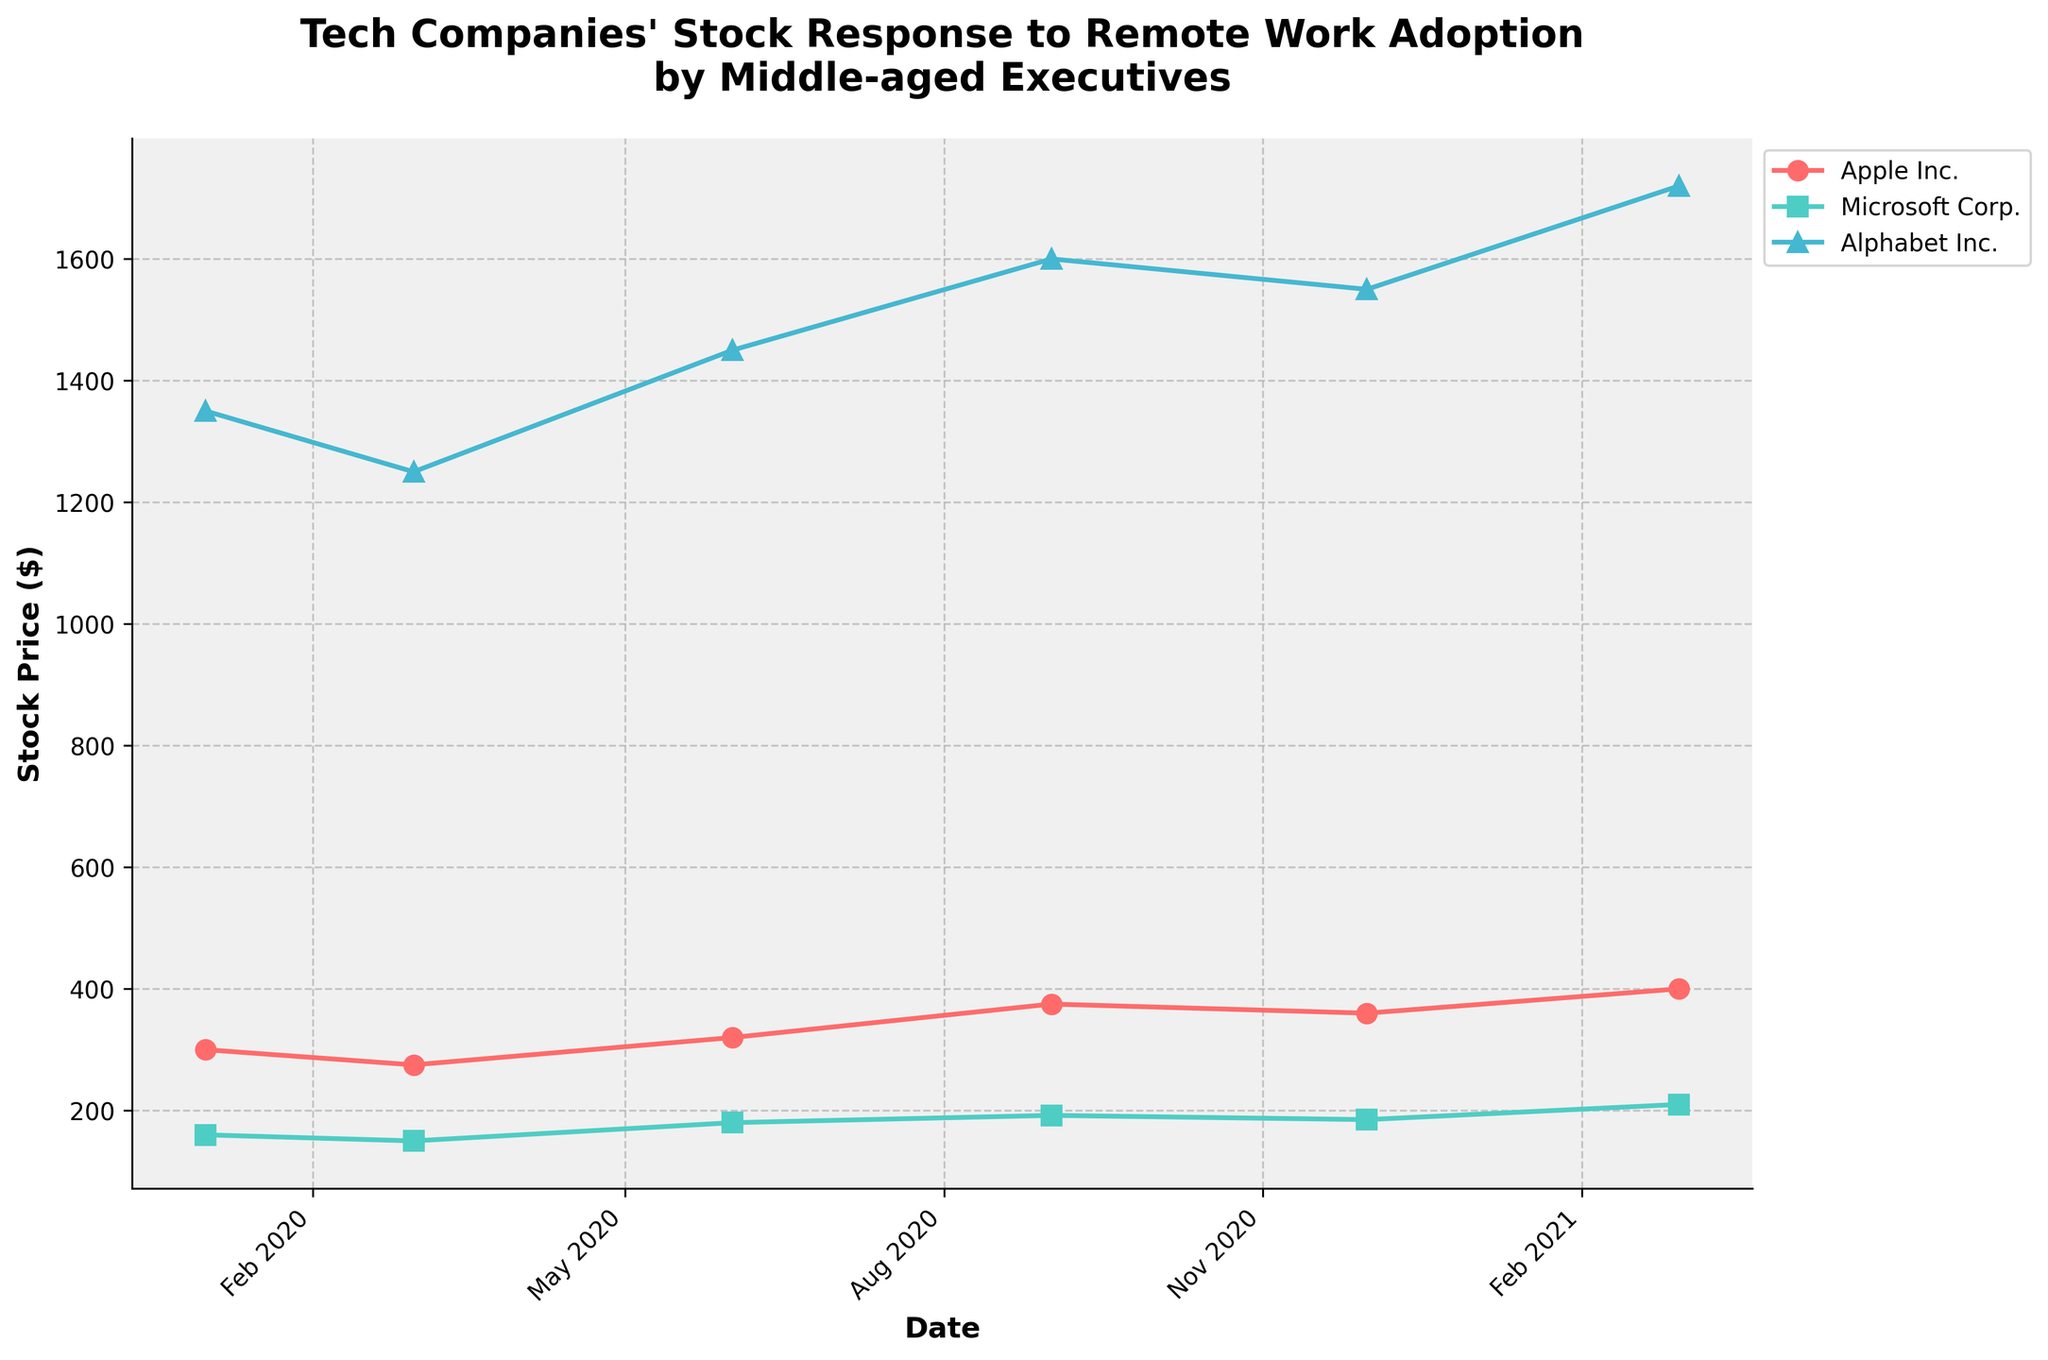What is the title of the plot? The title is typically located at the top center of the plot. It provides a summary of what the plot represents.
Answer: Tech Companies' Stock Response to Remote Work Adoption by Middle-aged Executives Which tech company had the highest stock price on September 1, 2020? Look at the data points for September 1, 2020, and compare the stock prices of Apple Inc., Microsoft Corp., and Alphabet Inc.
Answer: Alphabet Inc How did Apple's stock price change from March 1, 2020, to June 1, 2020? Identify Apple's stock price on March 1, 2020, and June 1, 2020, and then calculate the difference between these two values (320 - 275).
Answer: Increased by $45 Between which two dates did Microsoft Corp.'s stock price increase the most? Check the stock prices for Microsoft Corp. on all provided dates, and identify which sequential dates show the largest difference.
Answer: December 1, 2020 to March 1, 2021 What is the average stock price of Alphabet Inc. across all dates shown? Sum up all the stock prices of Alphabet Inc. and divide by the number of data points (1350 + 1250 + 1450 + 1600 + 1550 + 1720) / 6.
Answer: $1486.67 Which company exhibited the most consistent growth in stock prices over the given periods? Compare the trend lines of each company. The company with the least fluctuations and a steady upward trend indicates consistent growth.
Answer: Microsoft Corp Did any company’s stock price decrease over any of the given intervals? Observe the stock price trend lines for each company to find any period where the stock price falls.
Answer: Yes, Apple Inc. from January 1, 2020 to March 1, 2020 Which quarter saw the largest overall increase in stock prices for all companies? Break down the data into quarters and sum the stock price increases for Apple Inc., Microsoft Corp., and Alphabet Inc. to determine which quarter had the highest cumulative increase.
Answer: Q1 2021 What is the difference in stock price of Alphabet Inc. between the start (January 2020) and the latest date (March 2021)? Subtract the stock price of Alphabet Inc. on January 1, 2020, from its stock price on March 1, 2021 (1720 - 1350).
Answer: $370 How often were stock prices recorded in the dataset? Look at the x-axis dates and determine the frequency of recorded data points.
Answer: Quarterly 